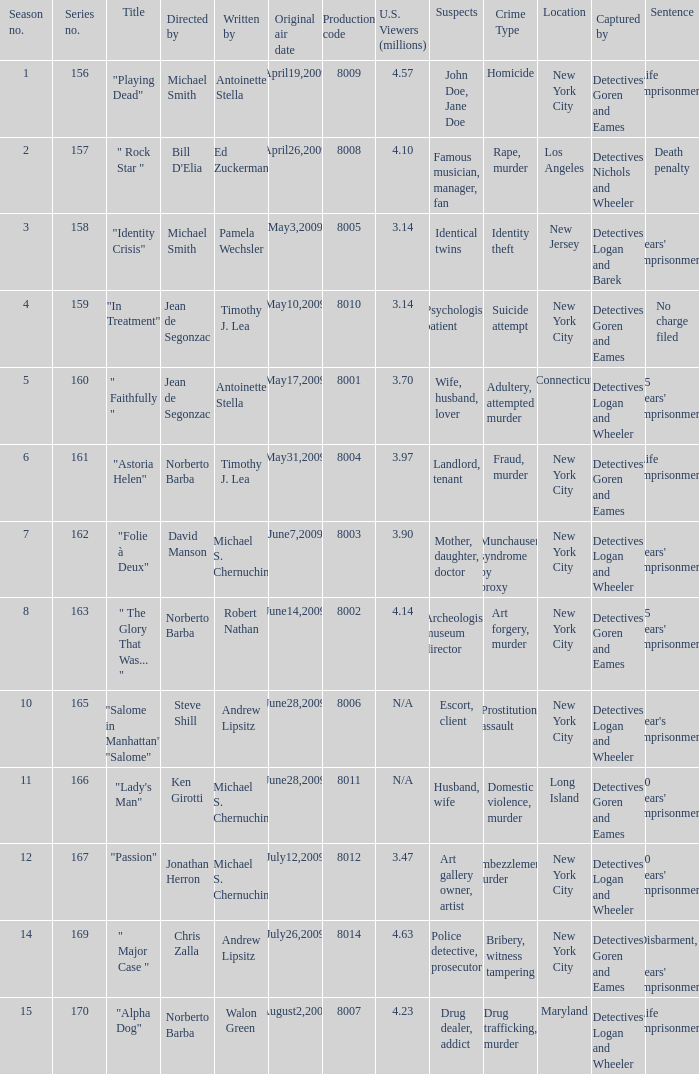Who are the writers when the production code is 8011? Michael S. Chernuchin. 